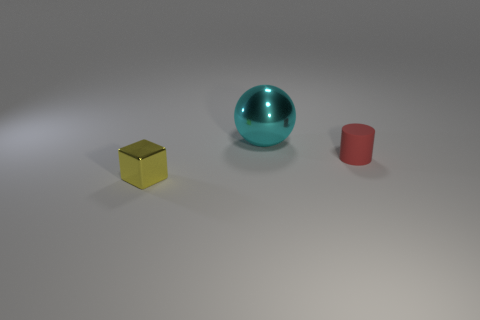What shape is the thing that is on the left side of the large cyan metallic thing?
Offer a terse response. Cube. Is the number of tiny red things greater than the number of large metallic cylinders?
Offer a terse response. Yes. What number of objects are either metallic objects right of the yellow object or metallic things that are behind the tiny red matte cylinder?
Offer a terse response. 1. How many things are both in front of the cyan metal ball and to the left of the red matte cylinder?
Make the answer very short. 1. Do the tiny yellow thing and the red cylinder have the same material?
Provide a short and direct response. No. There is a thing behind the tiny thing to the right of the tiny object that is to the left of the small matte cylinder; what is its shape?
Your response must be concise. Sphere. What is the thing that is on the left side of the small rubber thing and behind the cube made of?
Ensure brevity in your answer.  Metal. What color is the object behind the small thing behind the shiny object in front of the large cyan metallic ball?
Offer a terse response. Cyan. How many yellow objects are either metallic things or rubber cylinders?
Offer a terse response. 1. How many other objects are there of the same size as the cyan ball?
Offer a terse response. 0. 